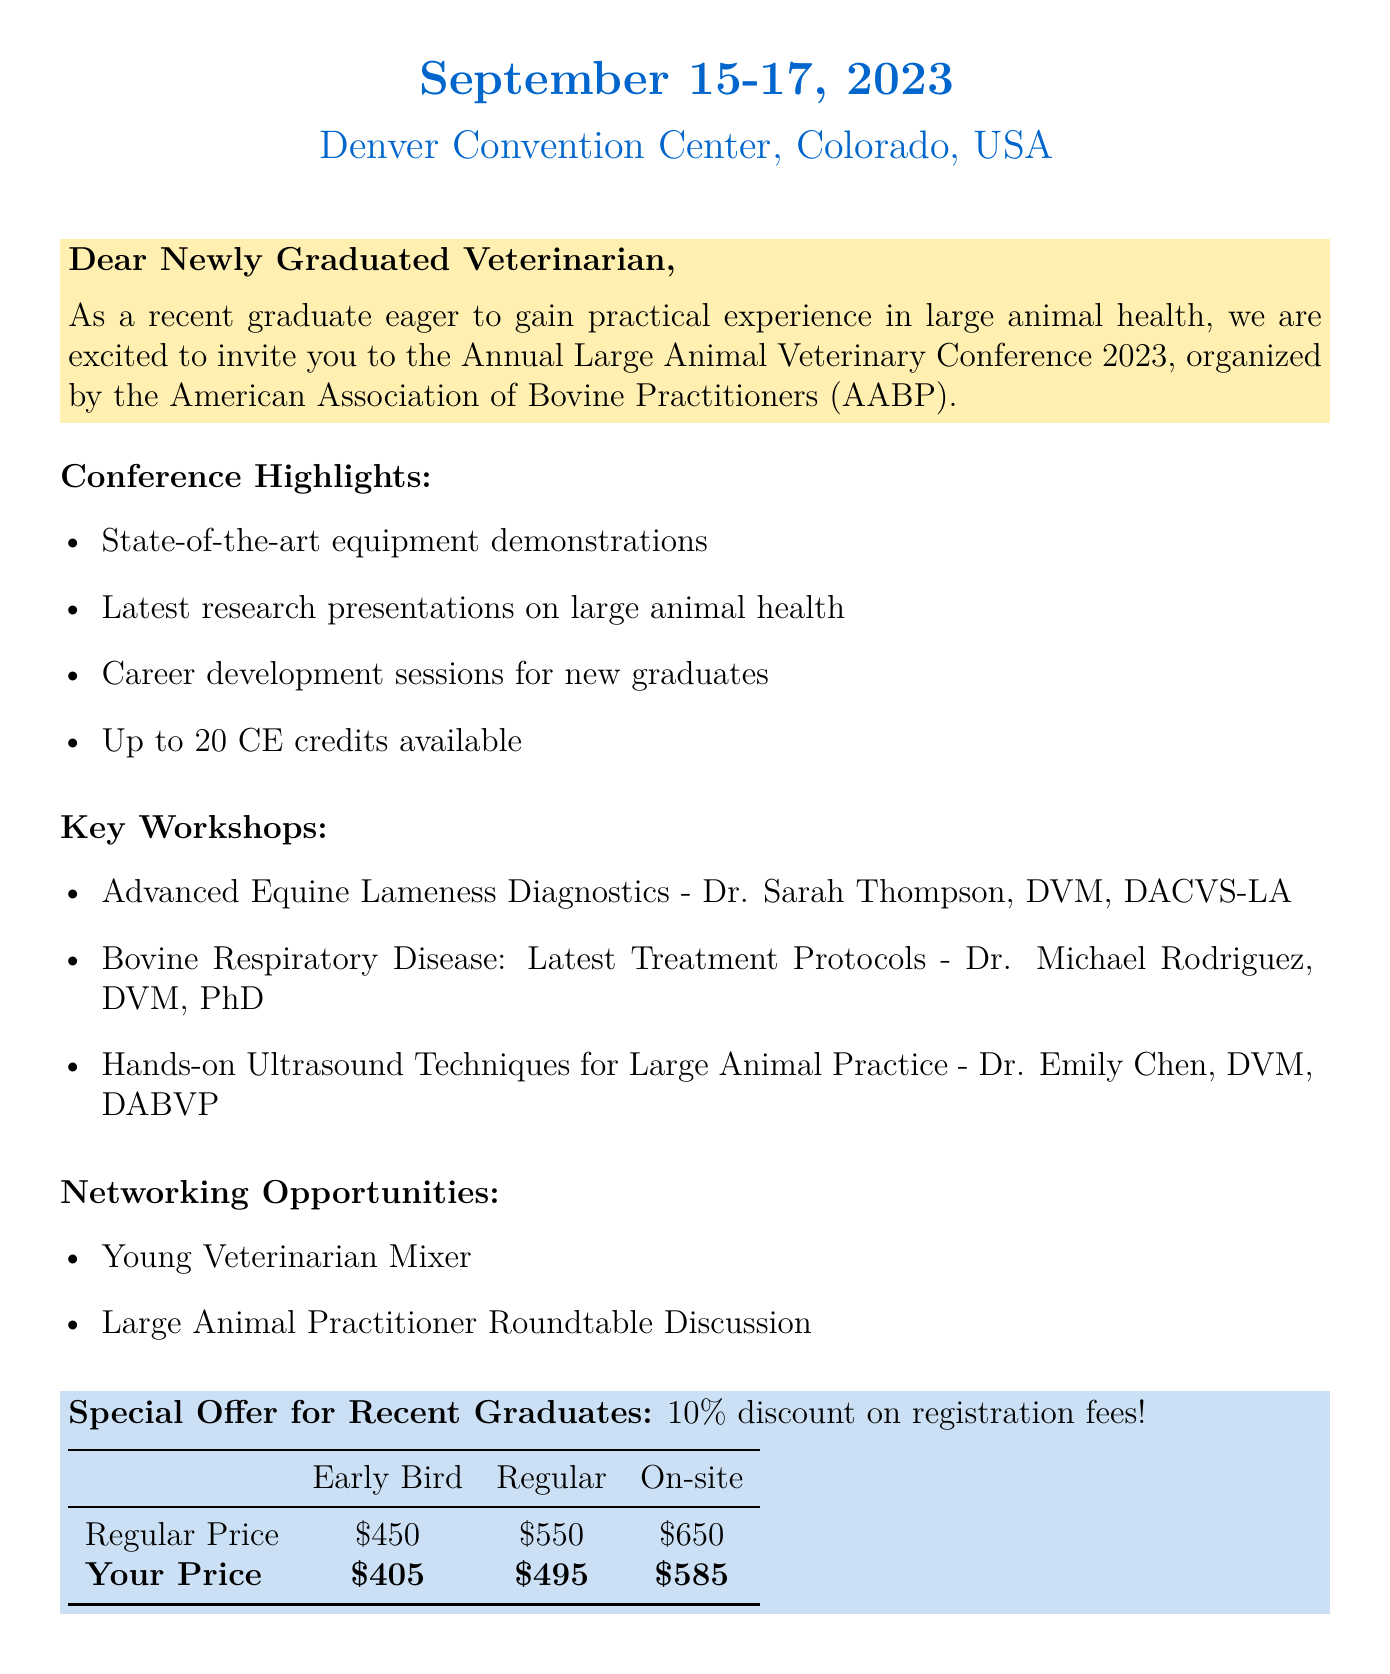What are the dates of the conference? The conference takes place from September 15 to September 17, 2023.
Answer: September 15-17, 2023 Who is the organizer of the event? The document states that the American Association of Bovine Practitioners (AABP) is the organizer.
Answer: American Association of Bovine Practitioners (AABP) What is the registration fee for early bird registration? The early bird registration fee is listed in the document as $450.
Answer: $450 How many continuing education credits are available? The document mentions that attendees can earn up to 20 CE credits.
Answer: Up to 20 CE credits Which workshop presents the latest treatment protocols for bovine respiratory disease? The document highlights "Bovine Respiratory Disease: Latest Treatment Protocols" as a workshop on that topic.
Answer: Bovine Respiratory Disease: Latest Treatment Protocols What is the special offer for recent graduates? The document states that recent graduates receive a 10% discount on registration fees.
Answer: 10% discount for recent graduates What networking opportunity is available for young veterinarians? The document mentions a "Young Veterinarian Mixer" as a networking opportunity.
Answer: Young Veterinarian Mixer Who will be presenting the workshop on advanced equine lameness diagnostics? The workshop title indicates that Dr. Sarah Thompson will present this workshop.
Answer: Dr. Sarah Thompson, DVM, DACVS-LA 